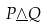<formula> <loc_0><loc_0><loc_500><loc_500>P \underline { \wedge } Q</formula> 